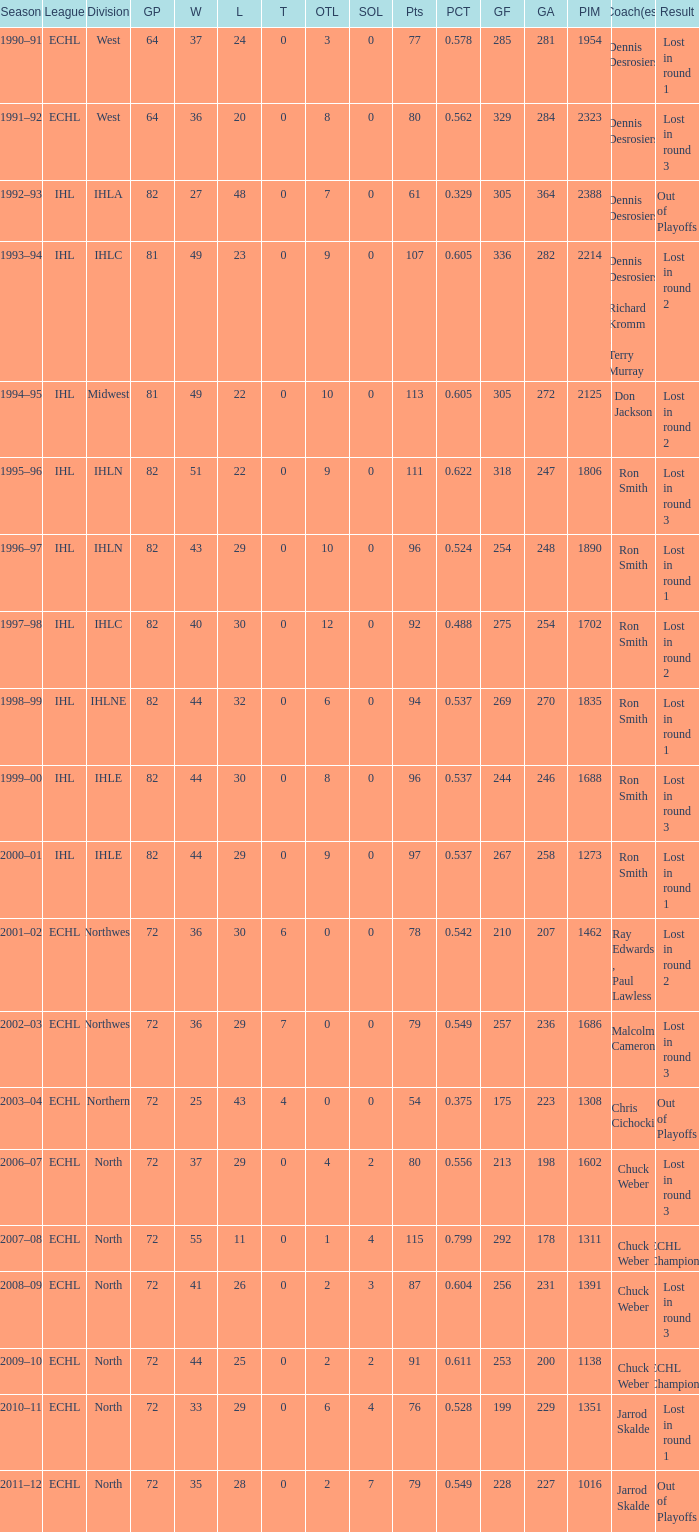If l is 28, what is the maximum otl? 2.0. 